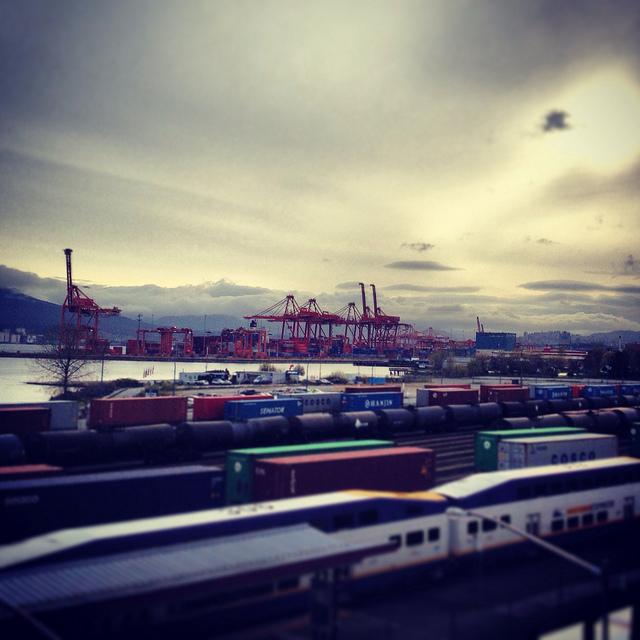What color is the shipping container in the bottom center?
Short answer required. Red. Is it night or day?
Answer briefly. Day. Is this an airport?
Short answer required. No. Is the weather photoshopped in?
Give a very brief answer. No. What color is the train?
Write a very short answer. White. What is the color of the sky?
Quick response, please. Gray. Overcast or sunny?
Keep it brief. Overcast. What method of mass transit is shown?
Keep it brief. Train. What scene is this located?
Quick response, please. Train yard. Is this a container terminal?
Give a very brief answer. Yes. What is the area the plane is parked on known as?
Short answer required. Runway. Are there planes?
Be succinct. No. What gets loaded onto trains in this area?
Write a very short answer. Cargo. 